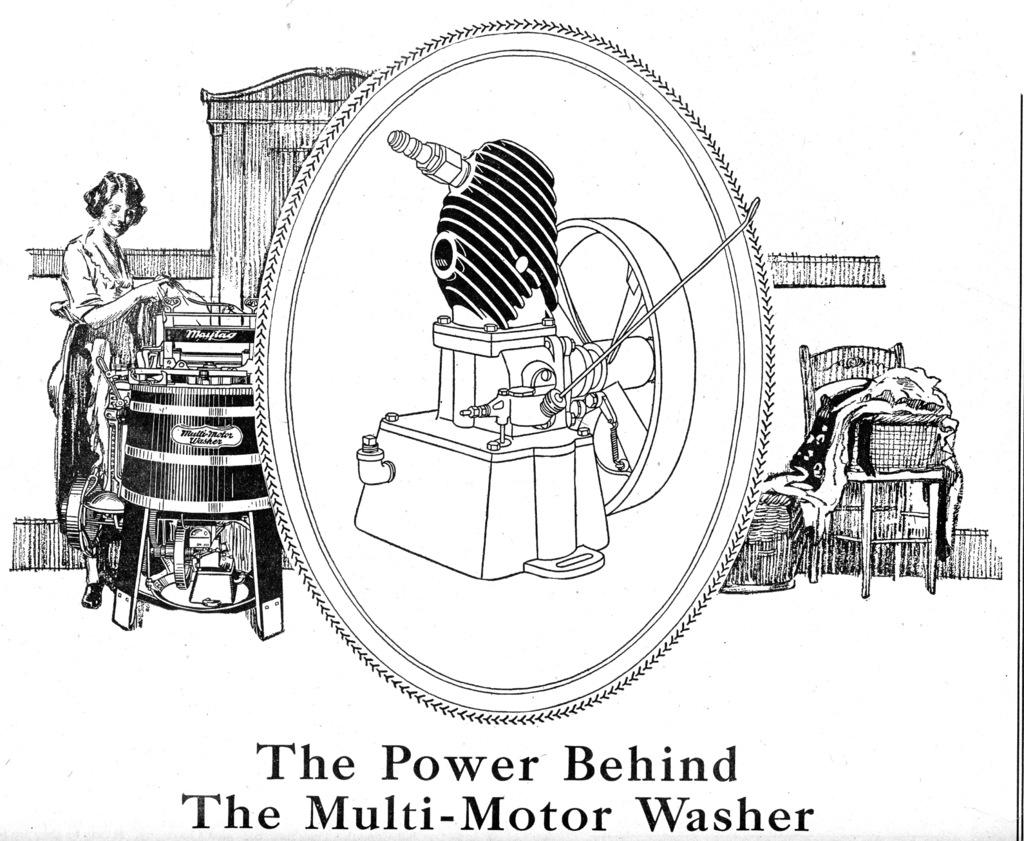Who is present in the image? There is a person and a baby in the image. What can be seen in the image besides the people? There is an equipment, a chair, and clothes visible in the image. What is written at the bottom of the image? There is a text visible at the bottom of the image. What type of beetle can be seen crawling on the baby's clothes in the image? There is no beetle present in the image; it only features a person, a baby, equipment, a chair, clothes, and text at the bottom. 